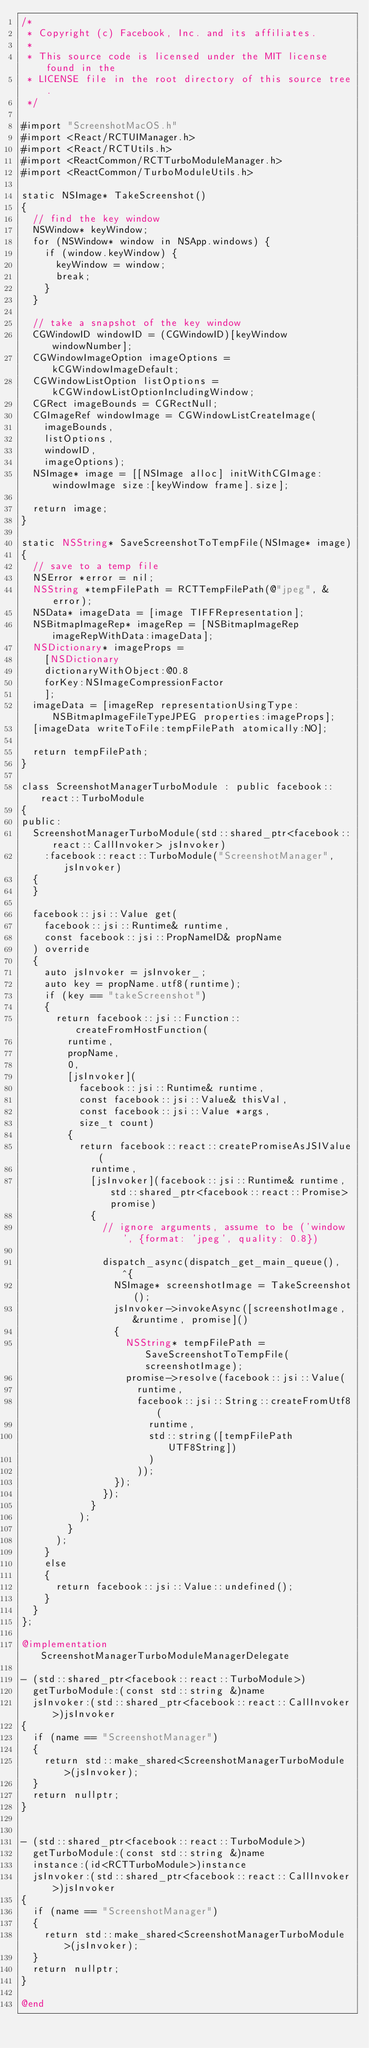<code> <loc_0><loc_0><loc_500><loc_500><_ObjectiveC_>/*
 * Copyright (c) Facebook, Inc. and its affiliates.
 *
 * This source code is licensed under the MIT license found in the
 * LICENSE file in the root directory of this source tree.
 */

#import "ScreenshotMacOS.h"
#import <React/RCTUIManager.h>
#import <React/RCTUtils.h>
#import <ReactCommon/RCTTurboModuleManager.h>
#import <ReactCommon/TurboModuleUtils.h>

static NSImage* TakeScreenshot()
{
  // find the key window
  NSWindow* keyWindow;
  for (NSWindow* window in NSApp.windows) {
    if (window.keyWindow) {
      keyWindow = window;
      break;
    }
  }

  // take a snapshot of the key window
  CGWindowID windowID = (CGWindowID)[keyWindow windowNumber];
  CGWindowImageOption imageOptions = kCGWindowImageDefault;
  CGWindowListOption listOptions = kCGWindowListOptionIncludingWindow;
  CGRect imageBounds = CGRectNull;
  CGImageRef windowImage = CGWindowListCreateImage(
    imageBounds,
    listOptions,
    windowID,
    imageOptions);
  NSImage* image = [[NSImage alloc] initWithCGImage:windowImage size:[keyWindow frame].size];
  
  return image;
}

static NSString* SaveScreenshotToTempFile(NSImage* image)
{
  // save to a temp file
  NSError *error = nil;
  NSString *tempFilePath = RCTTempFilePath(@"jpeg", &error);
  NSData* imageData = [image TIFFRepresentation];
  NSBitmapImageRep* imageRep = [NSBitmapImageRep imageRepWithData:imageData];
  NSDictionary* imageProps =
    [NSDictionary
    dictionaryWithObject:@0.8
    forKey:NSImageCompressionFactor
    ];
  imageData = [imageRep representationUsingType:NSBitmapImageFileTypeJPEG properties:imageProps];
  [imageData writeToFile:tempFilePath atomically:NO];
  
  return tempFilePath;
}

class ScreenshotManagerTurboModule : public facebook::react::TurboModule
{
public:
  ScreenshotManagerTurboModule(std::shared_ptr<facebook::react::CallInvoker> jsInvoker)
    :facebook::react::TurboModule("ScreenshotManager", jsInvoker)
  {
  }
  
  facebook::jsi::Value get(
    facebook::jsi::Runtime& runtime,
    const facebook::jsi::PropNameID& propName
  ) override
  {
    auto jsInvoker = jsInvoker_;
    auto key = propName.utf8(runtime);
    if (key == "takeScreenshot")
    {
      return facebook::jsi::Function::createFromHostFunction(
        runtime,
        propName,
        0,
        [jsInvoker](
          facebook::jsi::Runtime& runtime,
          const facebook::jsi::Value& thisVal,
          const facebook::jsi::Value *args,
          size_t count)
        {
          return facebook::react::createPromiseAsJSIValue(
            runtime,
            [jsInvoker](facebook::jsi::Runtime& runtime, std::shared_ptr<facebook::react::Promise> promise)
            {
              // ignore arguments, assume to be ('window', {format: 'jpeg', quality: 0.8})

              dispatch_async(dispatch_get_main_queue(), ^{
                NSImage* screenshotImage = TakeScreenshot();
                jsInvoker->invokeAsync([screenshotImage, &runtime, promise]()
                {
                  NSString* tempFilePath = SaveScreenshotToTempFile(screenshotImage);
                  promise->resolve(facebook::jsi::Value(
                    runtime,
                    facebook::jsi::String::createFromUtf8(
                      runtime,
                      std::string([tempFilePath UTF8String])
                      )
                    ));
                });
              });
            }
          );
        }
      );
    }
    else
    {
      return facebook::jsi::Value::undefined();
    }
  }
};

@implementation ScreenshotManagerTurboModuleManagerDelegate

- (std::shared_ptr<facebook::react::TurboModule>)
  getTurboModule:(const std::string &)name
  jsInvoker:(std::shared_ptr<facebook::react::CallInvoker>)jsInvoker
{
  if (name == "ScreenshotManager")
  {
    return std::make_shared<ScreenshotManagerTurboModule>(jsInvoker);
  }
  return nullptr;
}


- (std::shared_ptr<facebook::react::TurboModule>)
  getTurboModule:(const std::string &)name
  instance:(id<RCTTurboModule>)instance
  jsInvoker:(std::shared_ptr<facebook::react::CallInvoker>)jsInvoker
{
  if (name == "ScreenshotManager")
  {
    return std::make_shared<ScreenshotManagerTurboModule>(jsInvoker);
  }
  return nullptr;
}

@end
</code> 